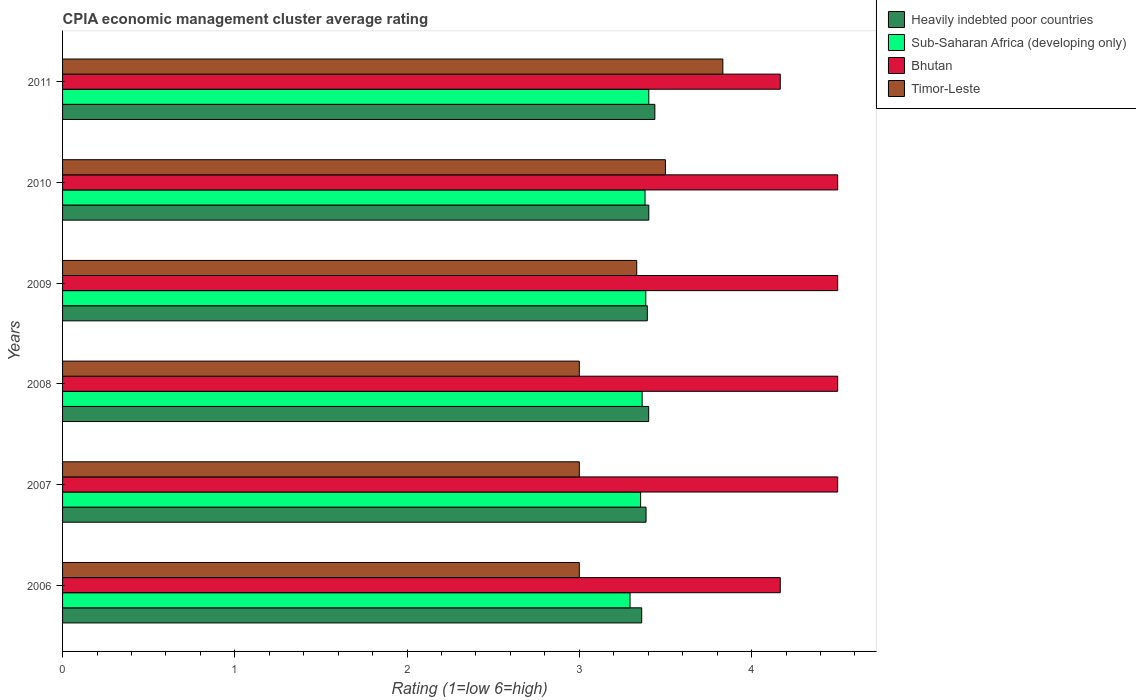Are the number of bars per tick equal to the number of legend labels?
Offer a very short reply. Yes. Are the number of bars on each tick of the Y-axis equal?
Ensure brevity in your answer.  Yes. How many bars are there on the 4th tick from the top?
Your response must be concise. 4. How many bars are there on the 5th tick from the bottom?
Your answer should be very brief. 4. What is the label of the 6th group of bars from the top?
Keep it short and to the point. 2006. What is the CPIA rating in Heavily indebted poor countries in 2006?
Provide a short and direct response. 3.36. In which year was the CPIA rating in Timor-Leste maximum?
Ensure brevity in your answer.  2011. What is the total CPIA rating in Heavily indebted poor countries in the graph?
Offer a very short reply. 20.39. What is the difference between the CPIA rating in Heavily indebted poor countries in 2007 and that in 2008?
Give a very brief answer. -0.02. What is the difference between the CPIA rating in Heavily indebted poor countries in 2008 and the CPIA rating in Bhutan in 2007?
Your answer should be compact. -1.1. What is the average CPIA rating in Bhutan per year?
Provide a succinct answer. 4.39. In the year 2006, what is the difference between the CPIA rating in Timor-Leste and CPIA rating in Bhutan?
Keep it short and to the point. -1.17. What is the ratio of the CPIA rating in Bhutan in 2010 to that in 2011?
Make the answer very short. 1.08. Is the CPIA rating in Heavily indebted poor countries in 2009 less than that in 2010?
Offer a terse response. Yes. What is the difference between the highest and the second highest CPIA rating in Timor-Leste?
Offer a terse response. 0.33. What is the difference between the highest and the lowest CPIA rating in Heavily indebted poor countries?
Keep it short and to the point. 0.08. In how many years, is the CPIA rating in Timor-Leste greater than the average CPIA rating in Timor-Leste taken over all years?
Keep it short and to the point. 3. Is it the case that in every year, the sum of the CPIA rating in Heavily indebted poor countries and CPIA rating in Bhutan is greater than the sum of CPIA rating in Timor-Leste and CPIA rating in Sub-Saharan Africa (developing only)?
Make the answer very short. No. What does the 2nd bar from the top in 2011 represents?
Provide a short and direct response. Bhutan. What does the 1st bar from the bottom in 2008 represents?
Your answer should be very brief. Heavily indebted poor countries. Is it the case that in every year, the sum of the CPIA rating in Timor-Leste and CPIA rating in Bhutan is greater than the CPIA rating in Sub-Saharan Africa (developing only)?
Your answer should be compact. Yes. How many bars are there?
Make the answer very short. 24. Are all the bars in the graph horizontal?
Offer a very short reply. Yes. What is the difference between two consecutive major ticks on the X-axis?
Provide a short and direct response. 1. Does the graph contain grids?
Make the answer very short. No. Where does the legend appear in the graph?
Offer a terse response. Top right. How many legend labels are there?
Offer a very short reply. 4. How are the legend labels stacked?
Your answer should be very brief. Vertical. What is the title of the graph?
Your answer should be compact. CPIA economic management cluster average rating. What is the label or title of the Y-axis?
Give a very brief answer. Years. What is the Rating (1=low 6=high) in Heavily indebted poor countries in 2006?
Provide a short and direct response. 3.36. What is the Rating (1=low 6=high) of Sub-Saharan Africa (developing only) in 2006?
Your answer should be compact. 3.29. What is the Rating (1=low 6=high) of Bhutan in 2006?
Offer a terse response. 4.17. What is the Rating (1=low 6=high) of Timor-Leste in 2006?
Make the answer very short. 3. What is the Rating (1=low 6=high) of Heavily indebted poor countries in 2007?
Ensure brevity in your answer.  3.39. What is the Rating (1=low 6=high) of Sub-Saharan Africa (developing only) in 2007?
Provide a short and direct response. 3.36. What is the Rating (1=low 6=high) in Heavily indebted poor countries in 2008?
Offer a terse response. 3.4. What is the Rating (1=low 6=high) in Sub-Saharan Africa (developing only) in 2008?
Keep it short and to the point. 3.36. What is the Rating (1=low 6=high) in Timor-Leste in 2008?
Provide a short and direct response. 3. What is the Rating (1=low 6=high) in Heavily indebted poor countries in 2009?
Provide a succinct answer. 3.39. What is the Rating (1=low 6=high) of Sub-Saharan Africa (developing only) in 2009?
Offer a terse response. 3.39. What is the Rating (1=low 6=high) in Timor-Leste in 2009?
Make the answer very short. 3.33. What is the Rating (1=low 6=high) of Heavily indebted poor countries in 2010?
Provide a succinct answer. 3.4. What is the Rating (1=low 6=high) in Sub-Saharan Africa (developing only) in 2010?
Provide a short and direct response. 3.38. What is the Rating (1=low 6=high) of Bhutan in 2010?
Your response must be concise. 4.5. What is the Rating (1=low 6=high) of Heavily indebted poor countries in 2011?
Make the answer very short. 3.44. What is the Rating (1=low 6=high) in Sub-Saharan Africa (developing only) in 2011?
Offer a terse response. 3.4. What is the Rating (1=low 6=high) in Bhutan in 2011?
Your answer should be very brief. 4.17. What is the Rating (1=low 6=high) in Timor-Leste in 2011?
Keep it short and to the point. 3.83. Across all years, what is the maximum Rating (1=low 6=high) in Heavily indebted poor countries?
Make the answer very short. 3.44. Across all years, what is the maximum Rating (1=low 6=high) of Sub-Saharan Africa (developing only)?
Your response must be concise. 3.4. Across all years, what is the maximum Rating (1=low 6=high) of Timor-Leste?
Give a very brief answer. 3.83. Across all years, what is the minimum Rating (1=low 6=high) of Heavily indebted poor countries?
Offer a very short reply. 3.36. Across all years, what is the minimum Rating (1=low 6=high) in Sub-Saharan Africa (developing only)?
Keep it short and to the point. 3.29. Across all years, what is the minimum Rating (1=low 6=high) in Bhutan?
Make the answer very short. 4.17. What is the total Rating (1=low 6=high) of Heavily indebted poor countries in the graph?
Offer a terse response. 20.39. What is the total Rating (1=low 6=high) in Sub-Saharan Africa (developing only) in the graph?
Keep it short and to the point. 20.19. What is the total Rating (1=low 6=high) in Bhutan in the graph?
Provide a short and direct response. 26.33. What is the total Rating (1=low 6=high) in Timor-Leste in the graph?
Offer a very short reply. 19.67. What is the difference between the Rating (1=low 6=high) of Heavily indebted poor countries in 2006 and that in 2007?
Your answer should be very brief. -0.03. What is the difference between the Rating (1=low 6=high) of Sub-Saharan Africa (developing only) in 2006 and that in 2007?
Keep it short and to the point. -0.06. What is the difference between the Rating (1=low 6=high) of Bhutan in 2006 and that in 2007?
Your answer should be compact. -0.33. What is the difference between the Rating (1=low 6=high) of Heavily indebted poor countries in 2006 and that in 2008?
Offer a terse response. -0.04. What is the difference between the Rating (1=low 6=high) of Sub-Saharan Africa (developing only) in 2006 and that in 2008?
Provide a succinct answer. -0.07. What is the difference between the Rating (1=low 6=high) of Heavily indebted poor countries in 2006 and that in 2009?
Your answer should be compact. -0.03. What is the difference between the Rating (1=low 6=high) in Sub-Saharan Africa (developing only) in 2006 and that in 2009?
Provide a short and direct response. -0.09. What is the difference between the Rating (1=low 6=high) in Bhutan in 2006 and that in 2009?
Make the answer very short. -0.33. What is the difference between the Rating (1=low 6=high) of Heavily indebted poor countries in 2006 and that in 2010?
Ensure brevity in your answer.  -0.04. What is the difference between the Rating (1=low 6=high) in Sub-Saharan Africa (developing only) in 2006 and that in 2010?
Your answer should be very brief. -0.09. What is the difference between the Rating (1=low 6=high) in Heavily indebted poor countries in 2006 and that in 2011?
Your answer should be compact. -0.08. What is the difference between the Rating (1=low 6=high) of Sub-Saharan Africa (developing only) in 2006 and that in 2011?
Make the answer very short. -0.11. What is the difference between the Rating (1=low 6=high) of Heavily indebted poor countries in 2007 and that in 2008?
Offer a very short reply. -0.02. What is the difference between the Rating (1=low 6=high) in Sub-Saharan Africa (developing only) in 2007 and that in 2008?
Offer a terse response. -0.01. What is the difference between the Rating (1=low 6=high) of Bhutan in 2007 and that in 2008?
Your answer should be compact. 0. What is the difference between the Rating (1=low 6=high) of Heavily indebted poor countries in 2007 and that in 2009?
Ensure brevity in your answer.  -0.01. What is the difference between the Rating (1=low 6=high) in Sub-Saharan Africa (developing only) in 2007 and that in 2009?
Give a very brief answer. -0.03. What is the difference between the Rating (1=low 6=high) in Heavily indebted poor countries in 2007 and that in 2010?
Offer a terse response. -0.02. What is the difference between the Rating (1=low 6=high) of Sub-Saharan Africa (developing only) in 2007 and that in 2010?
Provide a short and direct response. -0.03. What is the difference between the Rating (1=low 6=high) in Heavily indebted poor countries in 2007 and that in 2011?
Give a very brief answer. -0.05. What is the difference between the Rating (1=low 6=high) in Sub-Saharan Africa (developing only) in 2007 and that in 2011?
Your answer should be compact. -0.05. What is the difference between the Rating (1=low 6=high) of Bhutan in 2007 and that in 2011?
Make the answer very short. 0.33. What is the difference between the Rating (1=low 6=high) of Timor-Leste in 2007 and that in 2011?
Your response must be concise. -0.83. What is the difference between the Rating (1=low 6=high) in Heavily indebted poor countries in 2008 and that in 2009?
Offer a terse response. 0.01. What is the difference between the Rating (1=low 6=high) of Sub-Saharan Africa (developing only) in 2008 and that in 2009?
Offer a very short reply. -0.02. What is the difference between the Rating (1=low 6=high) in Bhutan in 2008 and that in 2009?
Keep it short and to the point. 0. What is the difference between the Rating (1=low 6=high) in Timor-Leste in 2008 and that in 2009?
Give a very brief answer. -0.33. What is the difference between the Rating (1=low 6=high) in Heavily indebted poor countries in 2008 and that in 2010?
Ensure brevity in your answer.  -0. What is the difference between the Rating (1=low 6=high) of Sub-Saharan Africa (developing only) in 2008 and that in 2010?
Give a very brief answer. -0.02. What is the difference between the Rating (1=low 6=high) in Heavily indebted poor countries in 2008 and that in 2011?
Offer a terse response. -0.04. What is the difference between the Rating (1=low 6=high) of Sub-Saharan Africa (developing only) in 2008 and that in 2011?
Offer a terse response. -0.04. What is the difference between the Rating (1=low 6=high) of Timor-Leste in 2008 and that in 2011?
Provide a short and direct response. -0.83. What is the difference between the Rating (1=low 6=high) in Heavily indebted poor countries in 2009 and that in 2010?
Provide a succinct answer. -0.01. What is the difference between the Rating (1=low 6=high) of Sub-Saharan Africa (developing only) in 2009 and that in 2010?
Give a very brief answer. 0. What is the difference between the Rating (1=low 6=high) in Bhutan in 2009 and that in 2010?
Your answer should be compact. 0. What is the difference between the Rating (1=low 6=high) in Timor-Leste in 2009 and that in 2010?
Offer a terse response. -0.17. What is the difference between the Rating (1=low 6=high) in Heavily indebted poor countries in 2009 and that in 2011?
Your answer should be compact. -0.04. What is the difference between the Rating (1=low 6=high) in Sub-Saharan Africa (developing only) in 2009 and that in 2011?
Offer a terse response. -0.02. What is the difference between the Rating (1=low 6=high) of Bhutan in 2009 and that in 2011?
Your answer should be very brief. 0.33. What is the difference between the Rating (1=low 6=high) of Timor-Leste in 2009 and that in 2011?
Make the answer very short. -0.5. What is the difference between the Rating (1=low 6=high) in Heavily indebted poor countries in 2010 and that in 2011?
Ensure brevity in your answer.  -0.04. What is the difference between the Rating (1=low 6=high) of Sub-Saharan Africa (developing only) in 2010 and that in 2011?
Offer a very short reply. -0.02. What is the difference between the Rating (1=low 6=high) in Bhutan in 2010 and that in 2011?
Your response must be concise. 0.33. What is the difference between the Rating (1=low 6=high) in Heavily indebted poor countries in 2006 and the Rating (1=low 6=high) in Sub-Saharan Africa (developing only) in 2007?
Ensure brevity in your answer.  0.01. What is the difference between the Rating (1=low 6=high) in Heavily indebted poor countries in 2006 and the Rating (1=low 6=high) in Bhutan in 2007?
Make the answer very short. -1.14. What is the difference between the Rating (1=low 6=high) in Heavily indebted poor countries in 2006 and the Rating (1=low 6=high) in Timor-Leste in 2007?
Your answer should be compact. 0.36. What is the difference between the Rating (1=low 6=high) of Sub-Saharan Africa (developing only) in 2006 and the Rating (1=low 6=high) of Bhutan in 2007?
Your answer should be compact. -1.21. What is the difference between the Rating (1=low 6=high) of Sub-Saharan Africa (developing only) in 2006 and the Rating (1=low 6=high) of Timor-Leste in 2007?
Your response must be concise. 0.29. What is the difference between the Rating (1=low 6=high) of Bhutan in 2006 and the Rating (1=low 6=high) of Timor-Leste in 2007?
Offer a very short reply. 1.17. What is the difference between the Rating (1=low 6=high) of Heavily indebted poor countries in 2006 and the Rating (1=low 6=high) of Sub-Saharan Africa (developing only) in 2008?
Ensure brevity in your answer.  -0. What is the difference between the Rating (1=low 6=high) in Heavily indebted poor countries in 2006 and the Rating (1=low 6=high) in Bhutan in 2008?
Provide a short and direct response. -1.14. What is the difference between the Rating (1=low 6=high) in Heavily indebted poor countries in 2006 and the Rating (1=low 6=high) in Timor-Leste in 2008?
Give a very brief answer. 0.36. What is the difference between the Rating (1=low 6=high) of Sub-Saharan Africa (developing only) in 2006 and the Rating (1=low 6=high) of Bhutan in 2008?
Ensure brevity in your answer.  -1.21. What is the difference between the Rating (1=low 6=high) in Sub-Saharan Africa (developing only) in 2006 and the Rating (1=low 6=high) in Timor-Leste in 2008?
Provide a succinct answer. 0.29. What is the difference between the Rating (1=low 6=high) of Heavily indebted poor countries in 2006 and the Rating (1=low 6=high) of Sub-Saharan Africa (developing only) in 2009?
Your answer should be very brief. -0.02. What is the difference between the Rating (1=low 6=high) in Heavily indebted poor countries in 2006 and the Rating (1=low 6=high) in Bhutan in 2009?
Offer a terse response. -1.14. What is the difference between the Rating (1=low 6=high) in Heavily indebted poor countries in 2006 and the Rating (1=low 6=high) in Timor-Leste in 2009?
Your response must be concise. 0.03. What is the difference between the Rating (1=low 6=high) of Sub-Saharan Africa (developing only) in 2006 and the Rating (1=low 6=high) of Bhutan in 2009?
Provide a short and direct response. -1.21. What is the difference between the Rating (1=low 6=high) in Sub-Saharan Africa (developing only) in 2006 and the Rating (1=low 6=high) in Timor-Leste in 2009?
Your answer should be very brief. -0.04. What is the difference between the Rating (1=low 6=high) of Heavily indebted poor countries in 2006 and the Rating (1=low 6=high) of Sub-Saharan Africa (developing only) in 2010?
Provide a short and direct response. -0.02. What is the difference between the Rating (1=low 6=high) in Heavily indebted poor countries in 2006 and the Rating (1=low 6=high) in Bhutan in 2010?
Ensure brevity in your answer.  -1.14. What is the difference between the Rating (1=low 6=high) of Heavily indebted poor countries in 2006 and the Rating (1=low 6=high) of Timor-Leste in 2010?
Your answer should be compact. -0.14. What is the difference between the Rating (1=low 6=high) in Sub-Saharan Africa (developing only) in 2006 and the Rating (1=low 6=high) in Bhutan in 2010?
Offer a terse response. -1.21. What is the difference between the Rating (1=low 6=high) in Sub-Saharan Africa (developing only) in 2006 and the Rating (1=low 6=high) in Timor-Leste in 2010?
Make the answer very short. -0.21. What is the difference between the Rating (1=low 6=high) of Heavily indebted poor countries in 2006 and the Rating (1=low 6=high) of Sub-Saharan Africa (developing only) in 2011?
Make the answer very short. -0.04. What is the difference between the Rating (1=low 6=high) in Heavily indebted poor countries in 2006 and the Rating (1=low 6=high) in Bhutan in 2011?
Provide a succinct answer. -0.8. What is the difference between the Rating (1=low 6=high) of Heavily indebted poor countries in 2006 and the Rating (1=low 6=high) of Timor-Leste in 2011?
Make the answer very short. -0.47. What is the difference between the Rating (1=low 6=high) in Sub-Saharan Africa (developing only) in 2006 and the Rating (1=low 6=high) in Bhutan in 2011?
Your answer should be very brief. -0.87. What is the difference between the Rating (1=low 6=high) in Sub-Saharan Africa (developing only) in 2006 and the Rating (1=low 6=high) in Timor-Leste in 2011?
Offer a very short reply. -0.54. What is the difference between the Rating (1=low 6=high) in Heavily indebted poor countries in 2007 and the Rating (1=low 6=high) in Sub-Saharan Africa (developing only) in 2008?
Provide a short and direct response. 0.02. What is the difference between the Rating (1=low 6=high) in Heavily indebted poor countries in 2007 and the Rating (1=low 6=high) in Bhutan in 2008?
Provide a succinct answer. -1.11. What is the difference between the Rating (1=low 6=high) in Heavily indebted poor countries in 2007 and the Rating (1=low 6=high) in Timor-Leste in 2008?
Keep it short and to the point. 0.39. What is the difference between the Rating (1=low 6=high) in Sub-Saharan Africa (developing only) in 2007 and the Rating (1=low 6=high) in Bhutan in 2008?
Provide a short and direct response. -1.14. What is the difference between the Rating (1=low 6=high) in Sub-Saharan Africa (developing only) in 2007 and the Rating (1=low 6=high) in Timor-Leste in 2008?
Provide a short and direct response. 0.36. What is the difference between the Rating (1=low 6=high) in Heavily indebted poor countries in 2007 and the Rating (1=low 6=high) in Sub-Saharan Africa (developing only) in 2009?
Provide a short and direct response. 0. What is the difference between the Rating (1=low 6=high) of Heavily indebted poor countries in 2007 and the Rating (1=low 6=high) of Bhutan in 2009?
Make the answer very short. -1.11. What is the difference between the Rating (1=low 6=high) in Heavily indebted poor countries in 2007 and the Rating (1=low 6=high) in Timor-Leste in 2009?
Make the answer very short. 0.05. What is the difference between the Rating (1=low 6=high) of Sub-Saharan Africa (developing only) in 2007 and the Rating (1=low 6=high) of Bhutan in 2009?
Ensure brevity in your answer.  -1.14. What is the difference between the Rating (1=low 6=high) in Sub-Saharan Africa (developing only) in 2007 and the Rating (1=low 6=high) in Timor-Leste in 2009?
Give a very brief answer. 0.02. What is the difference between the Rating (1=low 6=high) of Bhutan in 2007 and the Rating (1=low 6=high) of Timor-Leste in 2009?
Ensure brevity in your answer.  1.17. What is the difference between the Rating (1=low 6=high) in Heavily indebted poor countries in 2007 and the Rating (1=low 6=high) in Sub-Saharan Africa (developing only) in 2010?
Offer a very short reply. 0.01. What is the difference between the Rating (1=low 6=high) in Heavily indebted poor countries in 2007 and the Rating (1=low 6=high) in Bhutan in 2010?
Your response must be concise. -1.11. What is the difference between the Rating (1=low 6=high) in Heavily indebted poor countries in 2007 and the Rating (1=low 6=high) in Timor-Leste in 2010?
Your answer should be compact. -0.11. What is the difference between the Rating (1=low 6=high) of Sub-Saharan Africa (developing only) in 2007 and the Rating (1=low 6=high) of Bhutan in 2010?
Offer a very short reply. -1.14. What is the difference between the Rating (1=low 6=high) in Sub-Saharan Africa (developing only) in 2007 and the Rating (1=low 6=high) in Timor-Leste in 2010?
Keep it short and to the point. -0.14. What is the difference between the Rating (1=low 6=high) in Heavily indebted poor countries in 2007 and the Rating (1=low 6=high) in Sub-Saharan Africa (developing only) in 2011?
Your answer should be very brief. -0.02. What is the difference between the Rating (1=low 6=high) in Heavily indebted poor countries in 2007 and the Rating (1=low 6=high) in Bhutan in 2011?
Give a very brief answer. -0.78. What is the difference between the Rating (1=low 6=high) in Heavily indebted poor countries in 2007 and the Rating (1=low 6=high) in Timor-Leste in 2011?
Give a very brief answer. -0.45. What is the difference between the Rating (1=low 6=high) in Sub-Saharan Africa (developing only) in 2007 and the Rating (1=low 6=high) in Bhutan in 2011?
Provide a short and direct response. -0.81. What is the difference between the Rating (1=low 6=high) in Sub-Saharan Africa (developing only) in 2007 and the Rating (1=low 6=high) in Timor-Leste in 2011?
Offer a very short reply. -0.48. What is the difference between the Rating (1=low 6=high) in Bhutan in 2007 and the Rating (1=low 6=high) in Timor-Leste in 2011?
Provide a succinct answer. 0.67. What is the difference between the Rating (1=low 6=high) in Heavily indebted poor countries in 2008 and the Rating (1=low 6=high) in Sub-Saharan Africa (developing only) in 2009?
Offer a very short reply. 0.02. What is the difference between the Rating (1=low 6=high) in Heavily indebted poor countries in 2008 and the Rating (1=low 6=high) in Bhutan in 2009?
Give a very brief answer. -1.1. What is the difference between the Rating (1=low 6=high) of Heavily indebted poor countries in 2008 and the Rating (1=low 6=high) of Timor-Leste in 2009?
Offer a very short reply. 0.07. What is the difference between the Rating (1=low 6=high) in Sub-Saharan Africa (developing only) in 2008 and the Rating (1=low 6=high) in Bhutan in 2009?
Your answer should be compact. -1.14. What is the difference between the Rating (1=low 6=high) in Sub-Saharan Africa (developing only) in 2008 and the Rating (1=low 6=high) in Timor-Leste in 2009?
Offer a very short reply. 0.03. What is the difference between the Rating (1=low 6=high) in Heavily indebted poor countries in 2008 and the Rating (1=low 6=high) in Sub-Saharan Africa (developing only) in 2010?
Offer a very short reply. 0.02. What is the difference between the Rating (1=low 6=high) of Heavily indebted poor countries in 2008 and the Rating (1=low 6=high) of Bhutan in 2010?
Provide a succinct answer. -1.1. What is the difference between the Rating (1=low 6=high) in Heavily indebted poor countries in 2008 and the Rating (1=low 6=high) in Timor-Leste in 2010?
Your answer should be very brief. -0.1. What is the difference between the Rating (1=low 6=high) in Sub-Saharan Africa (developing only) in 2008 and the Rating (1=low 6=high) in Bhutan in 2010?
Provide a short and direct response. -1.14. What is the difference between the Rating (1=low 6=high) in Sub-Saharan Africa (developing only) in 2008 and the Rating (1=low 6=high) in Timor-Leste in 2010?
Provide a succinct answer. -0.14. What is the difference between the Rating (1=low 6=high) in Heavily indebted poor countries in 2008 and the Rating (1=low 6=high) in Sub-Saharan Africa (developing only) in 2011?
Keep it short and to the point. -0. What is the difference between the Rating (1=low 6=high) of Heavily indebted poor countries in 2008 and the Rating (1=low 6=high) of Bhutan in 2011?
Offer a very short reply. -0.76. What is the difference between the Rating (1=low 6=high) in Heavily indebted poor countries in 2008 and the Rating (1=low 6=high) in Timor-Leste in 2011?
Provide a succinct answer. -0.43. What is the difference between the Rating (1=low 6=high) in Sub-Saharan Africa (developing only) in 2008 and the Rating (1=low 6=high) in Bhutan in 2011?
Make the answer very short. -0.8. What is the difference between the Rating (1=low 6=high) in Sub-Saharan Africa (developing only) in 2008 and the Rating (1=low 6=high) in Timor-Leste in 2011?
Give a very brief answer. -0.47. What is the difference between the Rating (1=low 6=high) in Heavily indebted poor countries in 2009 and the Rating (1=low 6=high) in Sub-Saharan Africa (developing only) in 2010?
Provide a succinct answer. 0.01. What is the difference between the Rating (1=low 6=high) of Heavily indebted poor countries in 2009 and the Rating (1=low 6=high) of Bhutan in 2010?
Provide a succinct answer. -1.11. What is the difference between the Rating (1=low 6=high) in Heavily indebted poor countries in 2009 and the Rating (1=low 6=high) in Timor-Leste in 2010?
Give a very brief answer. -0.11. What is the difference between the Rating (1=low 6=high) in Sub-Saharan Africa (developing only) in 2009 and the Rating (1=low 6=high) in Bhutan in 2010?
Provide a succinct answer. -1.11. What is the difference between the Rating (1=low 6=high) in Sub-Saharan Africa (developing only) in 2009 and the Rating (1=low 6=high) in Timor-Leste in 2010?
Give a very brief answer. -0.11. What is the difference between the Rating (1=low 6=high) of Heavily indebted poor countries in 2009 and the Rating (1=low 6=high) of Sub-Saharan Africa (developing only) in 2011?
Ensure brevity in your answer.  -0.01. What is the difference between the Rating (1=low 6=high) in Heavily indebted poor countries in 2009 and the Rating (1=low 6=high) in Bhutan in 2011?
Make the answer very short. -0.77. What is the difference between the Rating (1=low 6=high) of Heavily indebted poor countries in 2009 and the Rating (1=low 6=high) of Timor-Leste in 2011?
Give a very brief answer. -0.44. What is the difference between the Rating (1=low 6=high) in Sub-Saharan Africa (developing only) in 2009 and the Rating (1=low 6=high) in Bhutan in 2011?
Make the answer very short. -0.78. What is the difference between the Rating (1=low 6=high) of Sub-Saharan Africa (developing only) in 2009 and the Rating (1=low 6=high) of Timor-Leste in 2011?
Keep it short and to the point. -0.45. What is the difference between the Rating (1=low 6=high) in Heavily indebted poor countries in 2010 and the Rating (1=low 6=high) in Bhutan in 2011?
Provide a short and direct response. -0.76. What is the difference between the Rating (1=low 6=high) of Heavily indebted poor countries in 2010 and the Rating (1=low 6=high) of Timor-Leste in 2011?
Provide a succinct answer. -0.43. What is the difference between the Rating (1=low 6=high) in Sub-Saharan Africa (developing only) in 2010 and the Rating (1=low 6=high) in Bhutan in 2011?
Keep it short and to the point. -0.79. What is the difference between the Rating (1=low 6=high) in Sub-Saharan Africa (developing only) in 2010 and the Rating (1=low 6=high) in Timor-Leste in 2011?
Provide a succinct answer. -0.45. What is the difference between the Rating (1=low 6=high) of Bhutan in 2010 and the Rating (1=low 6=high) of Timor-Leste in 2011?
Offer a terse response. 0.67. What is the average Rating (1=low 6=high) in Heavily indebted poor countries per year?
Ensure brevity in your answer.  3.4. What is the average Rating (1=low 6=high) in Sub-Saharan Africa (developing only) per year?
Offer a very short reply. 3.36. What is the average Rating (1=low 6=high) of Bhutan per year?
Make the answer very short. 4.39. What is the average Rating (1=low 6=high) of Timor-Leste per year?
Provide a succinct answer. 3.28. In the year 2006, what is the difference between the Rating (1=low 6=high) of Heavily indebted poor countries and Rating (1=low 6=high) of Sub-Saharan Africa (developing only)?
Ensure brevity in your answer.  0.07. In the year 2006, what is the difference between the Rating (1=low 6=high) in Heavily indebted poor countries and Rating (1=low 6=high) in Bhutan?
Your response must be concise. -0.8. In the year 2006, what is the difference between the Rating (1=low 6=high) of Heavily indebted poor countries and Rating (1=low 6=high) of Timor-Leste?
Offer a very short reply. 0.36. In the year 2006, what is the difference between the Rating (1=low 6=high) of Sub-Saharan Africa (developing only) and Rating (1=low 6=high) of Bhutan?
Offer a terse response. -0.87. In the year 2006, what is the difference between the Rating (1=low 6=high) of Sub-Saharan Africa (developing only) and Rating (1=low 6=high) of Timor-Leste?
Offer a terse response. 0.29. In the year 2006, what is the difference between the Rating (1=low 6=high) of Bhutan and Rating (1=low 6=high) of Timor-Leste?
Make the answer very short. 1.17. In the year 2007, what is the difference between the Rating (1=low 6=high) in Heavily indebted poor countries and Rating (1=low 6=high) in Sub-Saharan Africa (developing only)?
Your response must be concise. 0.03. In the year 2007, what is the difference between the Rating (1=low 6=high) in Heavily indebted poor countries and Rating (1=low 6=high) in Bhutan?
Your response must be concise. -1.11. In the year 2007, what is the difference between the Rating (1=low 6=high) of Heavily indebted poor countries and Rating (1=low 6=high) of Timor-Leste?
Your response must be concise. 0.39. In the year 2007, what is the difference between the Rating (1=low 6=high) of Sub-Saharan Africa (developing only) and Rating (1=low 6=high) of Bhutan?
Offer a very short reply. -1.14. In the year 2007, what is the difference between the Rating (1=low 6=high) of Sub-Saharan Africa (developing only) and Rating (1=low 6=high) of Timor-Leste?
Offer a very short reply. 0.36. In the year 2008, what is the difference between the Rating (1=low 6=high) of Heavily indebted poor countries and Rating (1=low 6=high) of Sub-Saharan Africa (developing only)?
Your response must be concise. 0.04. In the year 2008, what is the difference between the Rating (1=low 6=high) of Heavily indebted poor countries and Rating (1=low 6=high) of Bhutan?
Offer a very short reply. -1.1. In the year 2008, what is the difference between the Rating (1=low 6=high) in Heavily indebted poor countries and Rating (1=low 6=high) in Timor-Leste?
Keep it short and to the point. 0.4. In the year 2008, what is the difference between the Rating (1=low 6=high) in Sub-Saharan Africa (developing only) and Rating (1=low 6=high) in Bhutan?
Provide a short and direct response. -1.14. In the year 2008, what is the difference between the Rating (1=low 6=high) in Sub-Saharan Africa (developing only) and Rating (1=low 6=high) in Timor-Leste?
Your answer should be compact. 0.36. In the year 2008, what is the difference between the Rating (1=low 6=high) in Bhutan and Rating (1=low 6=high) in Timor-Leste?
Make the answer very short. 1.5. In the year 2009, what is the difference between the Rating (1=low 6=high) in Heavily indebted poor countries and Rating (1=low 6=high) in Sub-Saharan Africa (developing only)?
Ensure brevity in your answer.  0.01. In the year 2009, what is the difference between the Rating (1=low 6=high) in Heavily indebted poor countries and Rating (1=low 6=high) in Bhutan?
Provide a succinct answer. -1.11. In the year 2009, what is the difference between the Rating (1=low 6=high) in Heavily indebted poor countries and Rating (1=low 6=high) in Timor-Leste?
Your answer should be very brief. 0.06. In the year 2009, what is the difference between the Rating (1=low 6=high) of Sub-Saharan Africa (developing only) and Rating (1=low 6=high) of Bhutan?
Your response must be concise. -1.11. In the year 2009, what is the difference between the Rating (1=low 6=high) of Sub-Saharan Africa (developing only) and Rating (1=low 6=high) of Timor-Leste?
Your response must be concise. 0.05. In the year 2010, what is the difference between the Rating (1=low 6=high) of Heavily indebted poor countries and Rating (1=low 6=high) of Sub-Saharan Africa (developing only)?
Provide a short and direct response. 0.02. In the year 2010, what is the difference between the Rating (1=low 6=high) of Heavily indebted poor countries and Rating (1=low 6=high) of Bhutan?
Offer a very short reply. -1.1. In the year 2010, what is the difference between the Rating (1=low 6=high) of Heavily indebted poor countries and Rating (1=low 6=high) of Timor-Leste?
Give a very brief answer. -0.1. In the year 2010, what is the difference between the Rating (1=low 6=high) in Sub-Saharan Africa (developing only) and Rating (1=low 6=high) in Bhutan?
Offer a terse response. -1.12. In the year 2010, what is the difference between the Rating (1=low 6=high) of Sub-Saharan Africa (developing only) and Rating (1=low 6=high) of Timor-Leste?
Give a very brief answer. -0.12. In the year 2010, what is the difference between the Rating (1=low 6=high) of Bhutan and Rating (1=low 6=high) of Timor-Leste?
Provide a succinct answer. 1. In the year 2011, what is the difference between the Rating (1=low 6=high) in Heavily indebted poor countries and Rating (1=low 6=high) in Sub-Saharan Africa (developing only)?
Provide a succinct answer. 0.04. In the year 2011, what is the difference between the Rating (1=low 6=high) in Heavily indebted poor countries and Rating (1=low 6=high) in Bhutan?
Give a very brief answer. -0.73. In the year 2011, what is the difference between the Rating (1=low 6=high) in Heavily indebted poor countries and Rating (1=low 6=high) in Timor-Leste?
Offer a very short reply. -0.39. In the year 2011, what is the difference between the Rating (1=low 6=high) in Sub-Saharan Africa (developing only) and Rating (1=low 6=high) in Bhutan?
Your answer should be very brief. -0.76. In the year 2011, what is the difference between the Rating (1=low 6=high) of Sub-Saharan Africa (developing only) and Rating (1=low 6=high) of Timor-Leste?
Offer a very short reply. -0.43. What is the ratio of the Rating (1=low 6=high) of Heavily indebted poor countries in 2006 to that in 2007?
Your response must be concise. 0.99. What is the ratio of the Rating (1=low 6=high) in Sub-Saharan Africa (developing only) in 2006 to that in 2007?
Your answer should be very brief. 0.98. What is the ratio of the Rating (1=low 6=high) in Bhutan in 2006 to that in 2007?
Offer a terse response. 0.93. What is the ratio of the Rating (1=low 6=high) of Timor-Leste in 2006 to that in 2007?
Your answer should be compact. 1. What is the ratio of the Rating (1=low 6=high) of Heavily indebted poor countries in 2006 to that in 2008?
Ensure brevity in your answer.  0.99. What is the ratio of the Rating (1=low 6=high) of Sub-Saharan Africa (developing only) in 2006 to that in 2008?
Keep it short and to the point. 0.98. What is the ratio of the Rating (1=low 6=high) of Bhutan in 2006 to that in 2008?
Your response must be concise. 0.93. What is the ratio of the Rating (1=low 6=high) of Timor-Leste in 2006 to that in 2008?
Offer a very short reply. 1. What is the ratio of the Rating (1=low 6=high) in Heavily indebted poor countries in 2006 to that in 2009?
Provide a short and direct response. 0.99. What is the ratio of the Rating (1=low 6=high) in Bhutan in 2006 to that in 2009?
Keep it short and to the point. 0.93. What is the ratio of the Rating (1=low 6=high) in Timor-Leste in 2006 to that in 2009?
Your answer should be compact. 0.9. What is the ratio of the Rating (1=low 6=high) of Heavily indebted poor countries in 2006 to that in 2010?
Offer a terse response. 0.99. What is the ratio of the Rating (1=low 6=high) of Sub-Saharan Africa (developing only) in 2006 to that in 2010?
Give a very brief answer. 0.97. What is the ratio of the Rating (1=low 6=high) in Bhutan in 2006 to that in 2010?
Give a very brief answer. 0.93. What is the ratio of the Rating (1=low 6=high) of Heavily indebted poor countries in 2006 to that in 2011?
Your response must be concise. 0.98. What is the ratio of the Rating (1=low 6=high) of Timor-Leste in 2006 to that in 2011?
Make the answer very short. 0.78. What is the ratio of the Rating (1=low 6=high) of Bhutan in 2007 to that in 2008?
Keep it short and to the point. 1. What is the ratio of the Rating (1=low 6=high) of Timor-Leste in 2007 to that in 2008?
Offer a very short reply. 1. What is the ratio of the Rating (1=low 6=high) in Sub-Saharan Africa (developing only) in 2007 to that in 2009?
Your answer should be very brief. 0.99. What is the ratio of the Rating (1=low 6=high) of Bhutan in 2007 to that in 2009?
Provide a short and direct response. 1. What is the ratio of the Rating (1=low 6=high) of Bhutan in 2007 to that in 2010?
Your response must be concise. 1. What is the ratio of the Rating (1=low 6=high) in Heavily indebted poor countries in 2007 to that in 2011?
Your answer should be very brief. 0.99. What is the ratio of the Rating (1=low 6=high) in Sub-Saharan Africa (developing only) in 2007 to that in 2011?
Your answer should be very brief. 0.99. What is the ratio of the Rating (1=low 6=high) in Timor-Leste in 2007 to that in 2011?
Ensure brevity in your answer.  0.78. What is the ratio of the Rating (1=low 6=high) in Sub-Saharan Africa (developing only) in 2008 to that in 2009?
Provide a succinct answer. 0.99. What is the ratio of the Rating (1=low 6=high) in Bhutan in 2008 to that in 2009?
Ensure brevity in your answer.  1. What is the ratio of the Rating (1=low 6=high) of Timor-Leste in 2008 to that in 2009?
Ensure brevity in your answer.  0.9. What is the ratio of the Rating (1=low 6=high) in Heavily indebted poor countries in 2008 to that in 2010?
Ensure brevity in your answer.  1. What is the ratio of the Rating (1=low 6=high) in Bhutan in 2008 to that in 2010?
Provide a succinct answer. 1. What is the ratio of the Rating (1=low 6=high) of Bhutan in 2008 to that in 2011?
Give a very brief answer. 1.08. What is the ratio of the Rating (1=low 6=high) in Timor-Leste in 2008 to that in 2011?
Make the answer very short. 0.78. What is the ratio of the Rating (1=low 6=high) in Sub-Saharan Africa (developing only) in 2009 to that in 2010?
Provide a succinct answer. 1. What is the ratio of the Rating (1=low 6=high) in Bhutan in 2009 to that in 2010?
Make the answer very short. 1. What is the ratio of the Rating (1=low 6=high) in Heavily indebted poor countries in 2009 to that in 2011?
Keep it short and to the point. 0.99. What is the ratio of the Rating (1=low 6=high) of Sub-Saharan Africa (developing only) in 2009 to that in 2011?
Your response must be concise. 0.99. What is the ratio of the Rating (1=low 6=high) of Bhutan in 2009 to that in 2011?
Provide a short and direct response. 1.08. What is the ratio of the Rating (1=low 6=high) in Timor-Leste in 2009 to that in 2011?
Keep it short and to the point. 0.87. What is the ratio of the Rating (1=low 6=high) of Sub-Saharan Africa (developing only) in 2010 to that in 2011?
Offer a very short reply. 0.99. What is the difference between the highest and the second highest Rating (1=low 6=high) of Heavily indebted poor countries?
Make the answer very short. 0.04. What is the difference between the highest and the second highest Rating (1=low 6=high) in Sub-Saharan Africa (developing only)?
Your answer should be compact. 0.02. What is the difference between the highest and the second highest Rating (1=low 6=high) in Timor-Leste?
Offer a terse response. 0.33. What is the difference between the highest and the lowest Rating (1=low 6=high) in Heavily indebted poor countries?
Offer a very short reply. 0.08. What is the difference between the highest and the lowest Rating (1=low 6=high) of Sub-Saharan Africa (developing only)?
Provide a succinct answer. 0.11. What is the difference between the highest and the lowest Rating (1=low 6=high) of Timor-Leste?
Make the answer very short. 0.83. 